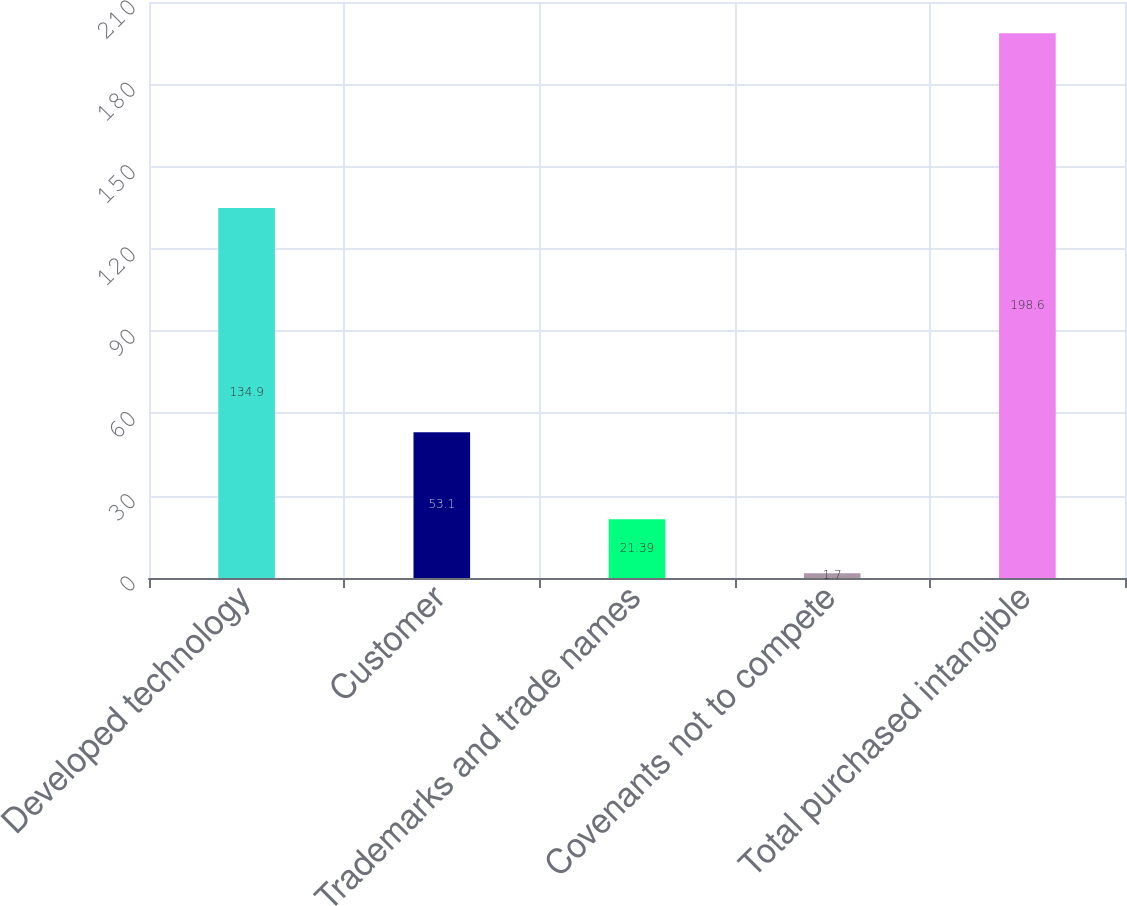Convert chart to OTSL. <chart><loc_0><loc_0><loc_500><loc_500><bar_chart><fcel>Developed technology<fcel>Customer<fcel>Trademarks and trade names<fcel>Covenants not to compete<fcel>Total purchased intangible<nl><fcel>134.9<fcel>53.1<fcel>21.39<fcel>1.7<fcel>198.6<nl></chart> 